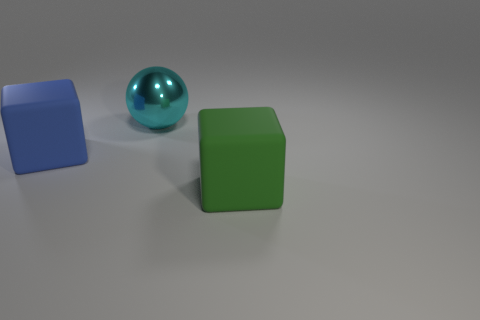Subtract 1 spheres. How many spheres are left? 0 Add 1 small purple things. How many small purple things exist? 1 Add 3 big blue things. How many objects exist? 6 Subtract 0 red balls. How many objects are left? 3 Subtract all blocks. How many objects are left? 1 Subtract all gray balls. Subtract all brown cubes. How many balls are left? 1 Subtract all brown blocks. How many green balls are left? 0 Subtract all tiny green balls. Subtract all matte blocks. How many objects are left? 1 Add 3 cyan objects. How many cyan objects are left? 4 